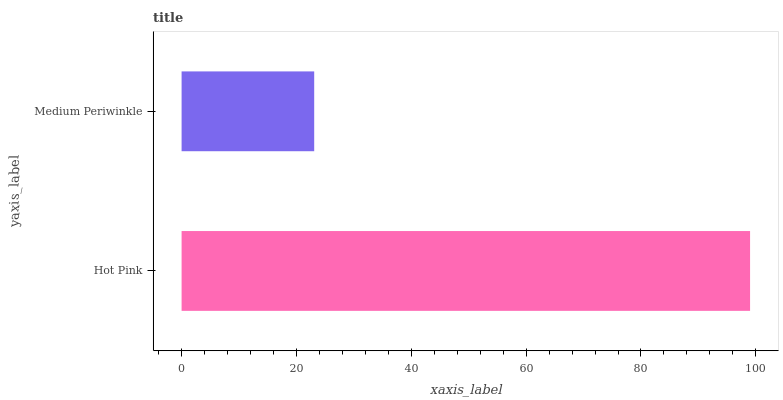Is Medium Periwinkle the minimum?
Answer yes or no. Yes. Is Hot Pink the maximum?
Answer yes or no. Yes. Is Medium Periwinkle the maximum?
Answer yes or no. No. Is Hot Pink greater than Medium Periwinkle?
Answer yes or no. Yes. Is Medium Periwinkle less than Hot Pink?
Answer yes or no. Yes. Is Medium Periwinkle greater than Hot Pink?
Answer yes or no. No. Is Hot Pink less than Medium Periwinkle?
Answer yes or no. No. Is Hot Pink the high median?
Answer yes or no. Yes. Is Medium Periwinkle the low median?
Answer yes or no. Yes. Is Medium Periwinkle the high median?
Answer yes or no. No. Is Hot Pink the low median?
Answer yes or no. No. 